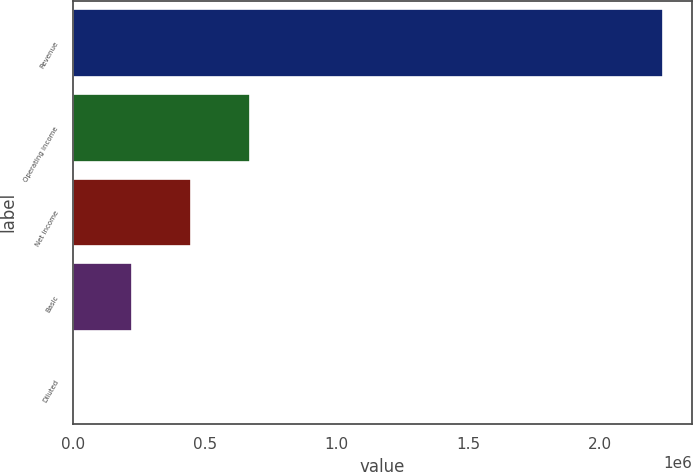Convert chart. <chart><loc_0><loc_0><loc_500><loc_500><bar_chart><fcel>Revenue<fcel>Operating income<fcel>Net income<fcel>Basic<fcel>Diluted<nl><fcel>2.23759e+06<fcel>671276<fcel>447518<fcel>223759<fcel>0.7<nl></chart> 